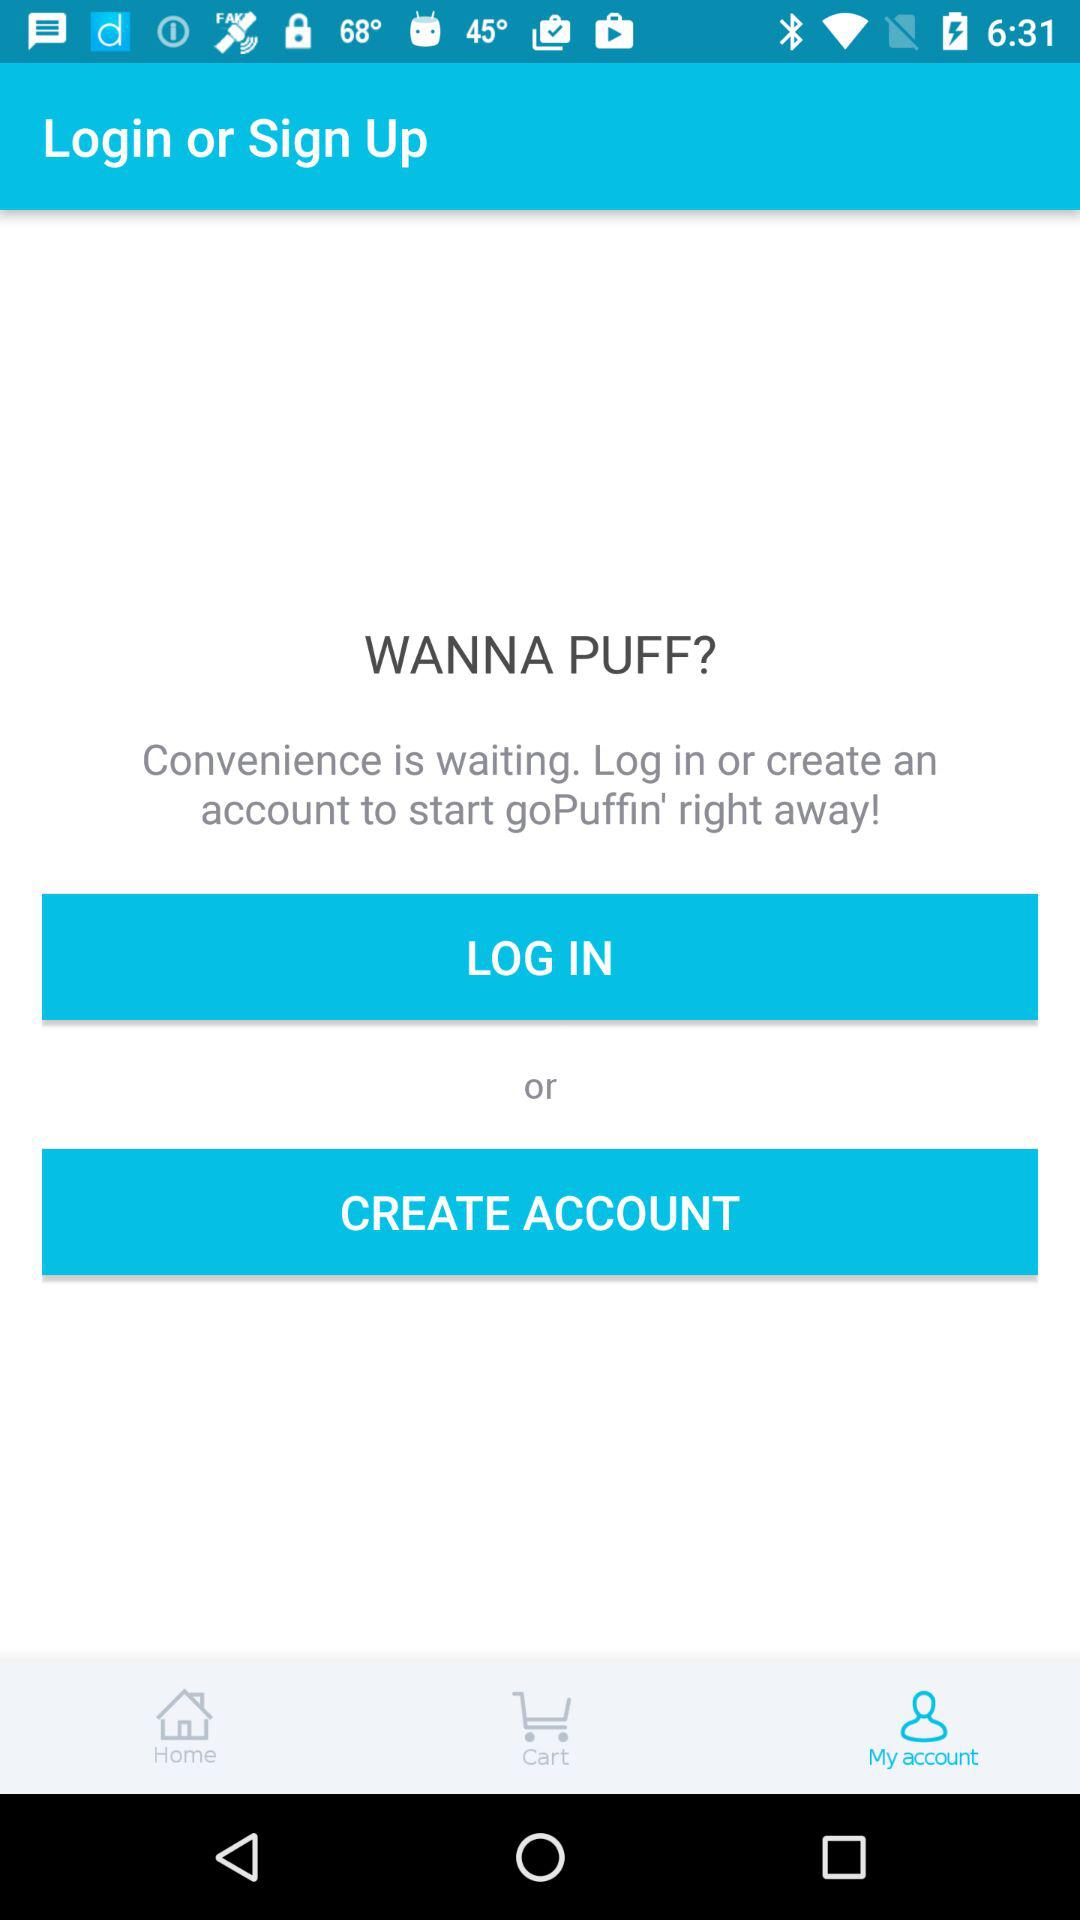What application is asking to log in? The application asking to log in is "goPuffin'". 